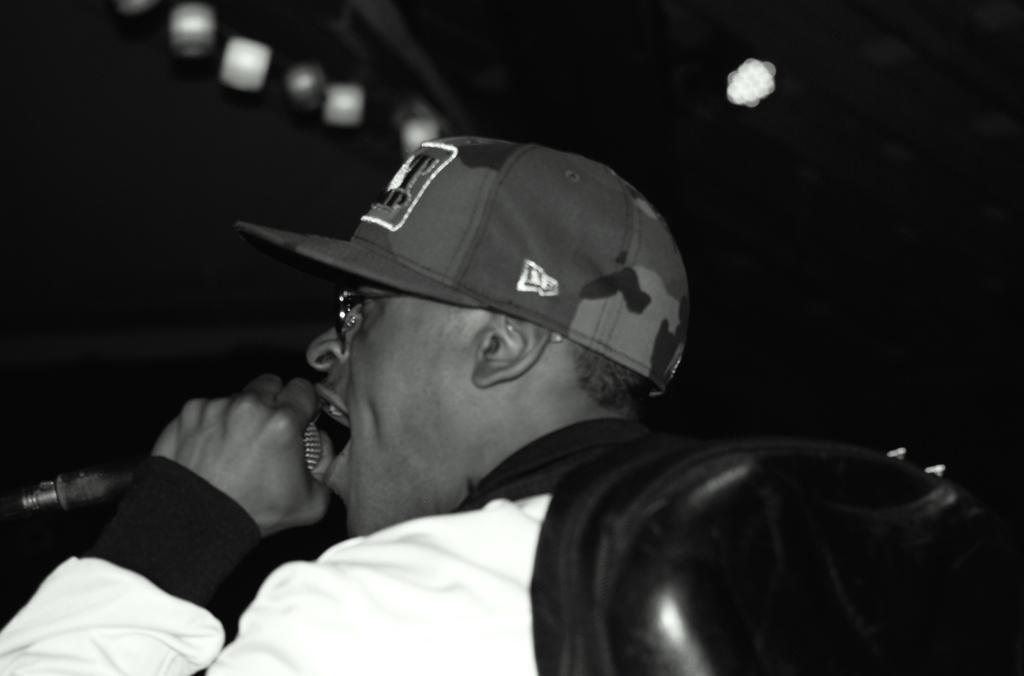Can you describe this image briefly? In this picture we can see a man holding a mike in his hand and singing. He wore a cap, spectacles. These are lights. Background is really dark. 